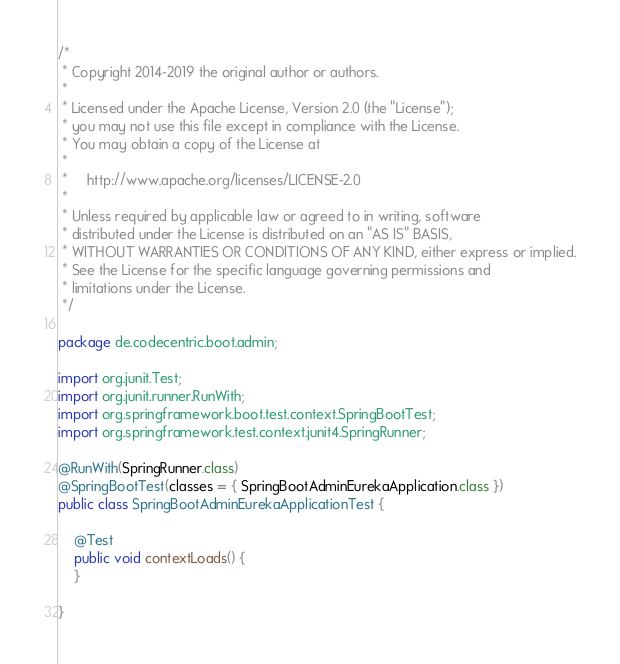<code> <loc_0><loc_0><loc_500><loc_500><_Java_>/*
 * Copyright 2014-2019 the original author or authors.
 *
 * Licensed under the Apache License, Version 2.0 (the "License");
 * you may not use this file except in compliance with the License.
 * You may obtain a copy of the License at
 *
 *     http://www.apache.org/licenses/LICENSE-2.0
 *
 * Unless required by applicable law or agreed to in writing, software
 * distributed under the License is distributed on an "AS IS" BASIS,
 * WITHOUT WARRANTIES OR CONDITIONS OF ANY KIND, either express or implied.
 * See the License for the specific language governing permissions and
 * limitations under the License.
 */

package de.codecentric.boot.admin;

import org.junit.Test;
import org.junit.runner.RunWith;
import org.springframework.boot.test.context.SpringBootTest;
import org.springframework.test.context.junit4.SpringRunner;

@RunWith(SpringRunner.class)
@SpringBootTest(classes = { SpringBootAdminEurekaApplication.class })
public class SpringBootAdminEurekaApplicationTest {

	@Test
	public void contextLoads() {
	}

}
</code> 